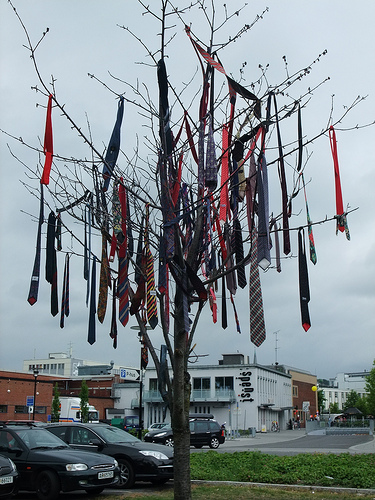<image>
Is the tie in the tree? Yes. The tie is contained within or inside the tree, showing a containment relationship. 